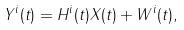Convert formula to latex. <formula><loc_0><loc_0><loc_500><loc_500>Y ^ { i } ( t ) = H ^ { i } ( t ) X ( t ) + W ^ { i } ( t ) ,</formula> 